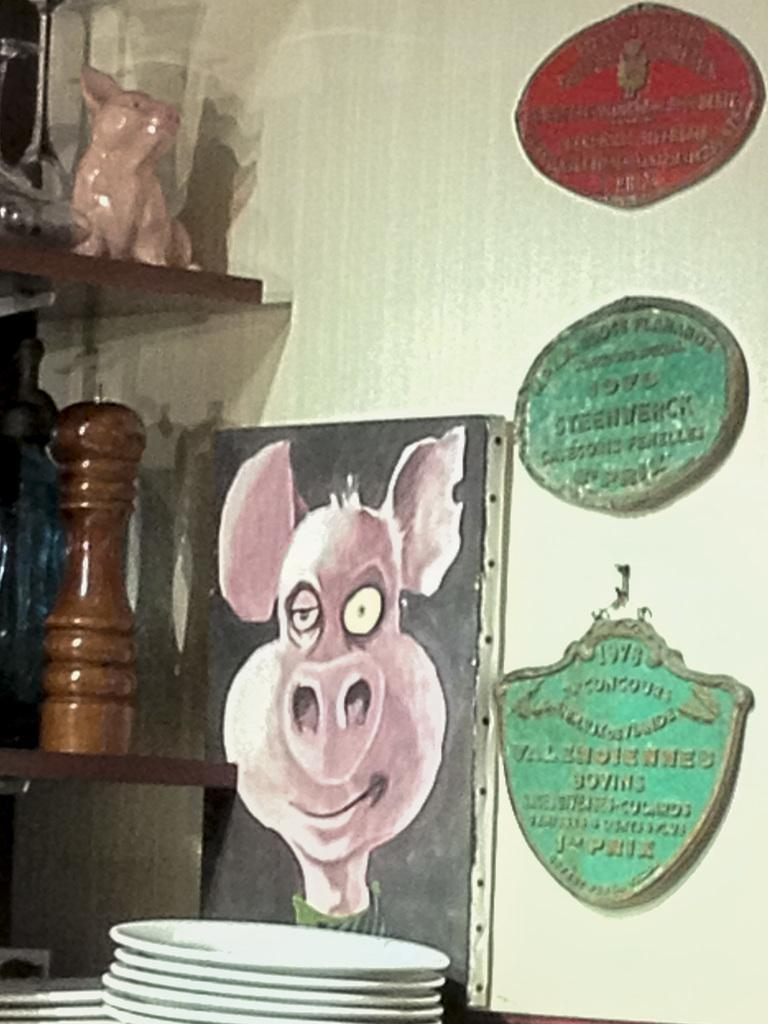What type of objects can be seen on the surface in the image? There are plates in the image. What can be seen on the wall in the image? There are boards on the wall in the image. What is located on the left side of the image? There is a toy on the left side of the image. Where are other objects placed in the image? There are objects on shelves in the image. How many cacti are present on the shelves in the image? There are no cacti present in the image; the shelves contain other objects. What type of calculator can be seen on the toy in the image? There is no calculator present in the image; the toy is not associated with any calculator. 